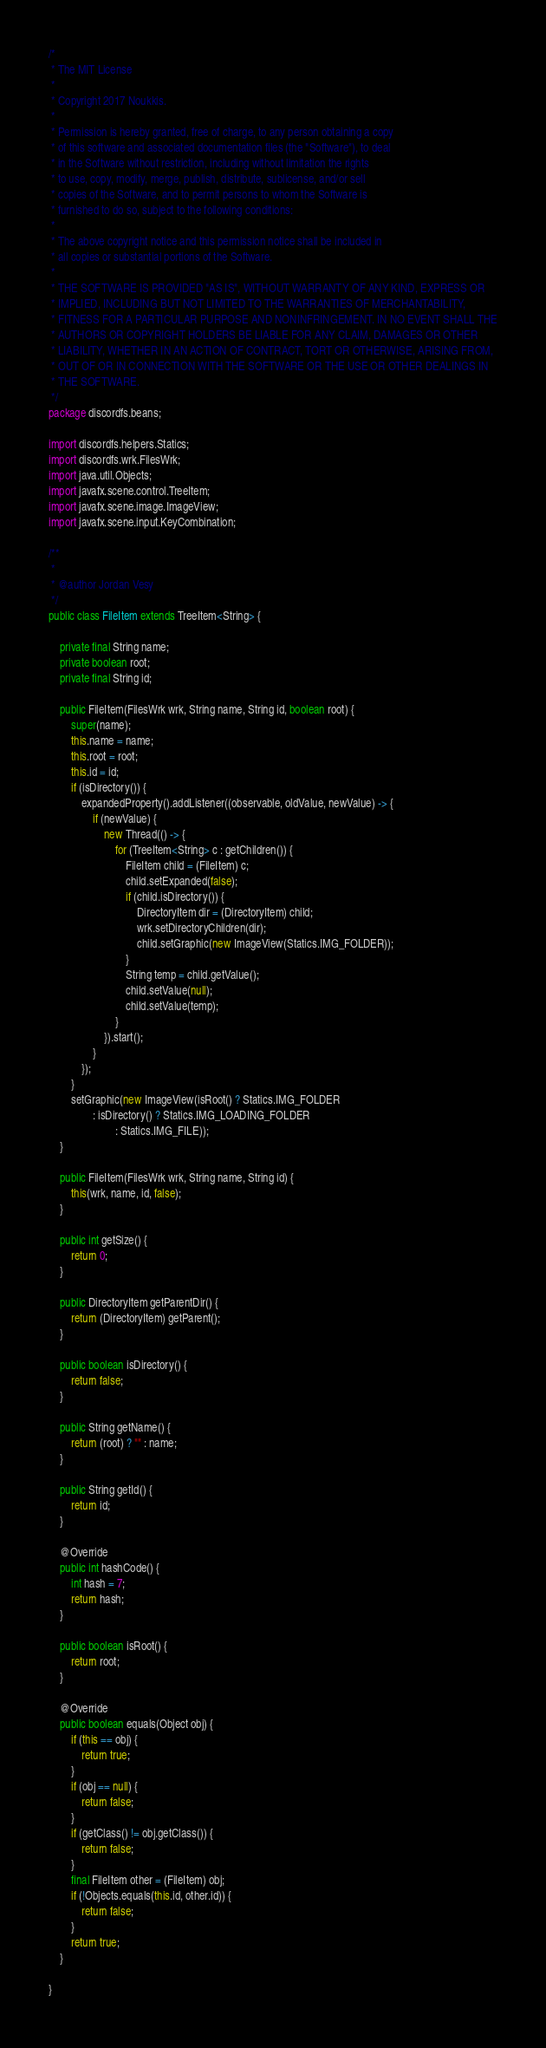<code> <loc_0><loc_0><loc_500><loc_500><_Java_>/*
 * The MIT License
 *
 * Copyright 2017 Noukkis.
 *
 * Permission is hereby granted, free of charge, to any person obtaining a copy
 * of this software and associated documentation files (the "Software"), to deal
 * in the Software without restriction, including without limitation the rights
 * to use, copy, modify, merge, publish, distribute, sublicense, and/or sell
 * copies of the Software, and to permit persons to whom the Software is
 * furnished to do so, subject to the following conditions:
 *
 * The above copyright notice and this permission notice shall be included in
 * all copies or substantial portions of the Software.
 *
 * THE SOFTWARE IS PROVIDED "AS IS", WITHOUT WARRANTY OF ANY KIND, EXPRESS OR
 * IMPLIED, INCLUDING BUT NOT LIMITED TO THE WARRANTIES OF MERCHANTABILITY,
 * FITNESS FOR A PARTICULAR PURPOSE AND NONINFRINGEMENT. IN NO EVENT SHALL THE
 * AUTHORS OR COPYRIGHT HOLDERS BE LIABLE FOR ANY CLAIM, DAMAGES OR OTHER
 * LIABILITY, WHETHER IN AN ACTION OF CONTRACT, TORT OR OTHERWISE, ARISING FROM,
 * OUT OF OR IN CONNECTION WITH THE SOFTWARE OR THE USE OR OTHER DEALINGS IN
 * THE SOFTWARE.
 */
package discordfs.beans;

import discordfs.helpers.Statics;
import discordfs.wrk.FilesWrk;
import java.util.Objects;
import javafx.scene.control.TreeItem;
import javafx.scene.image.ImageView;
import javafx.scene.input.KeyCombination;

/**
 *
 * @author Jordan Vesy
 */
public class FileItem extends TreeItem<String> {

    private final String name;
    private boolean root;
    private final String id;

    public FileItem(FilesWrk wrk, String name, String id, boolean root) {
        super(name);
        this.name = name;
        this.root = root;
        this.id = id;
        if (isDirectory()) {
            expandedProperty().addListener((observable, oldValue, newValue) -> {
                if (newValue) {
                    new Thread(() -> {
                        for (TreeItem<String> c : getChildren()) {
                            FileItem child = (FileItem) c;
                            child.setExpanded(false);
                            if (child.isDirectory()) {
                                DirectoryItem dir = (DirectoryItem) child;
                                wrk.setDirectoryChildren(dir);
                                child.setGraphic(new ImageView(Statics.IMG_FOLDER));
                            }
                            String temp = child.getValue();
                            child.setValue(null);
                            child.setValue(temp);
                        }
                    }).start();
                }
            });
        }
        setGraphic(new ImageView(isRoot() ? Statics.IMG_FOLDER
                : isDirectory() ? Statics.IMG_LOADING_FOLDER
                        : Statics.IMG_FILE));
    }

    public FileItem(FilesWrk wrk, String name, String id) {
        this(wrk, name, id, false);
    }

    public int getSize() {
        return 0;
    }

    public DirectoryItem getParentDir() {
        return (DirectoryItem) getParent();
    }

    public boolean isDirectory() {
        return false;
    }

    public String getName() {
        return (root) ? "" : name;
    }

    public String getId() {
        return id;
    }

    @Override
    public int hashCode() {
        int hash = 7;
        return hash;
    }

    public boolean isRoot() {
        return root;
    }

    @Override
    public boolean equals(Object obj) {
        if (this == obj) {
            return true;
        }
        if (obj == null) {
            return false;
        }
        if (getClass() != obj.getClass()) {
            return false;
        }
        final FileItem other = (FileItem) obj;
        if (!Objects.equals(this.id, other.id)) {
            return false;
        }
        return true;
    }

}
</code> 